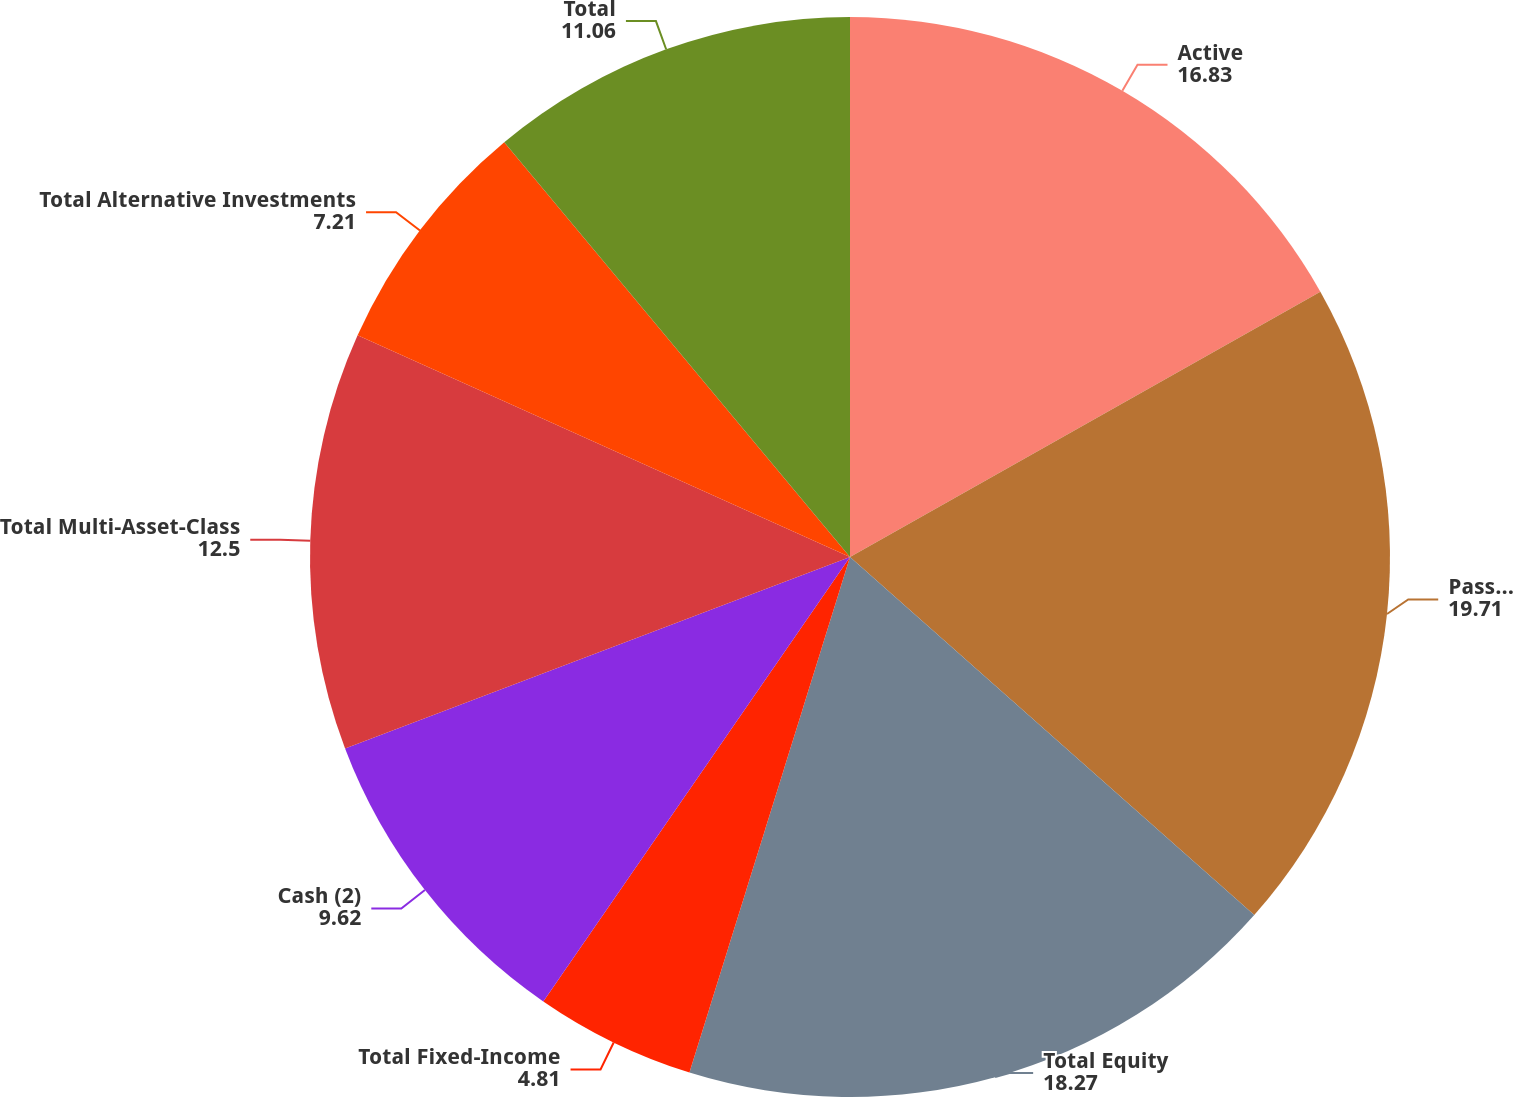<chart> <loc_0><loc_0><loc_500><loc_500><pie_chart><fcel>Active<fcel>Passive<fcel>Total Equity<fcel>Total Fixed-Income<fcel>Cash (2)<fcel>Total Multi-Asset-Class<fcel>Total Alternative Investments<fcel>Total<nl><fcel>16.83%<fcel>19.71%<fcel>18.27%<fcel>4.81%<fcel>9.62%<fcel>12.5%<fcel>7.21%<fcel>11.06%<nl></chart> 